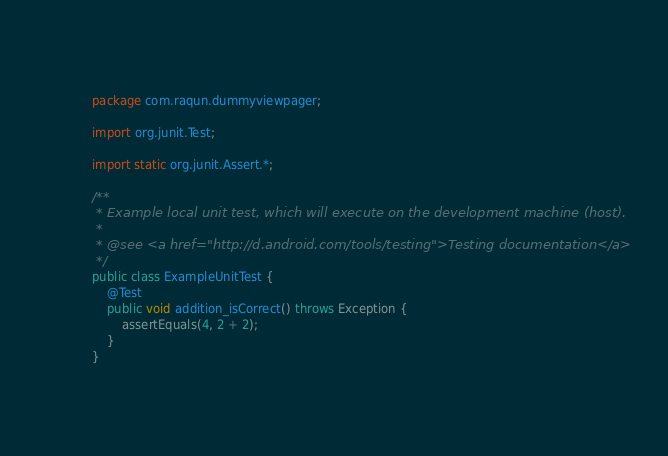<code> <loc_0><loc_0><loc_500><loc_500><_Java_>package com.raqun.dummyviewpager;

import org.junit.Test;

import static org.junit.Assert.*;

/**
 * Example local unit test, which will execute on the development machine (host).
 *
 * @see <a href="http://d.android.com/tools/testing">Testing documentation</a>
 */
public class ExampleUnitTest {
    @Test
    public void addition_isCorrect() throws Exception {
        assertEquals(4, 2 + 2);
    }
}</code> 